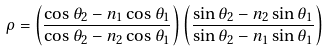Convert formula to latex. <formula><loc_0><loc_0><loc_500><loc_500>\rho = \left ( \frac { \cos \theta _ { 2 } - n _ { 1 } \cos \theta _ { 1 } } { \cos \theta _ { 2 } - n _ { 2 } \cos \theta _ { 1 } } \right ) \left ( \frac { \sin \theta _ { 2 } - n _ { 2 } \sin \theta _ { 1 } } { \sin \theta _ { 2 } - n _ { 1 } \sin \theta _ { 1 } } \right )</formula> 